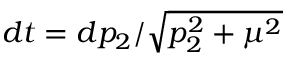<formula> <loc_0><loc_0><loc_500><loc_500>d t = d p _ { 2 } / \sqrt { p _ { 2 } ^ { 2 } + \mu ^ { 2 } }</formula> 